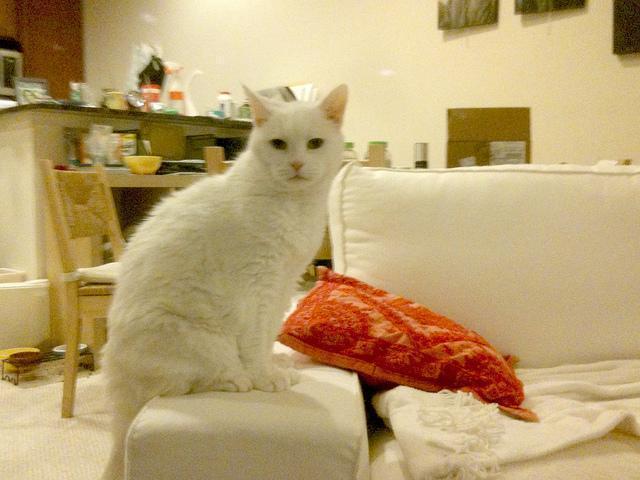How many pillows are in the photo?
Give a very brief answer. 1. How many chairs are in the picture?
Give a very brief answer. 2. How many watches is this man wearing?
Give a very brief answer. 0. 